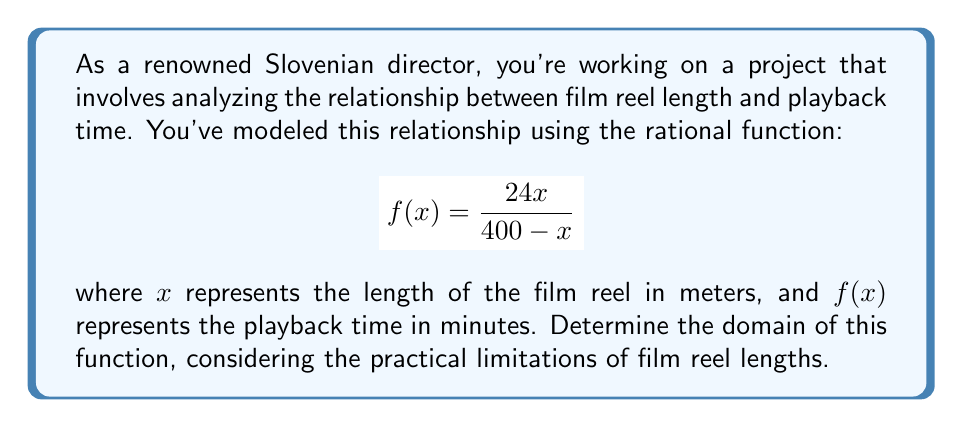Can you answer this question? To find the domain of this rational function, we need to consider both mathematical and practical constraints:

1. Mathematical constraint:
   The denominator of a rational function cannot be zero. So, we need to solve:
   $$400 - x \neq 0$$
   $$x \neq 400$$

2. Practical constraints:
   a) Film reel length cannot be negative: $x \geq 0$
   b) Film reel length is typically less than 400 meters: $x < 400$

3. Combining these constraints:
   $$0 \leq x < 400$$

4. In interval notation, this is written as $[0, 400)$

Note: The upper bound is exclusive (400) because at exactly 400 meters, the function would be undefined due to division by zero.
Answer: $[0, 400)$ 